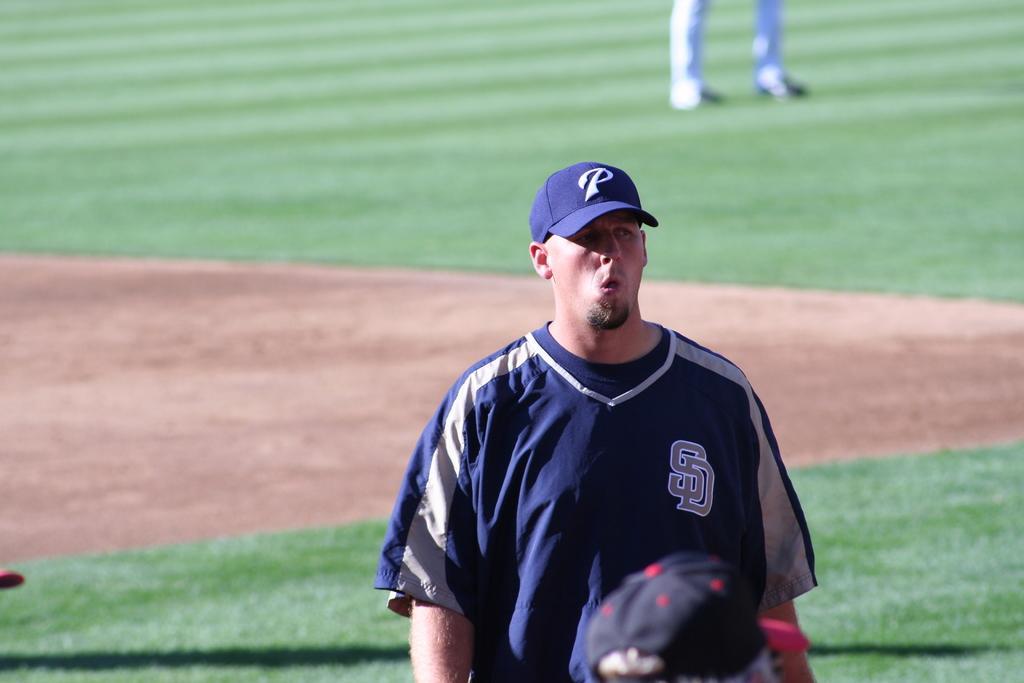In one or two sentences, can you explain what this image depicts? In this picture there is a man standing and wore a cap and we can see grass and ground. In the background of the image we can see legs of a person. At the bottom of the image we can see person's head. 